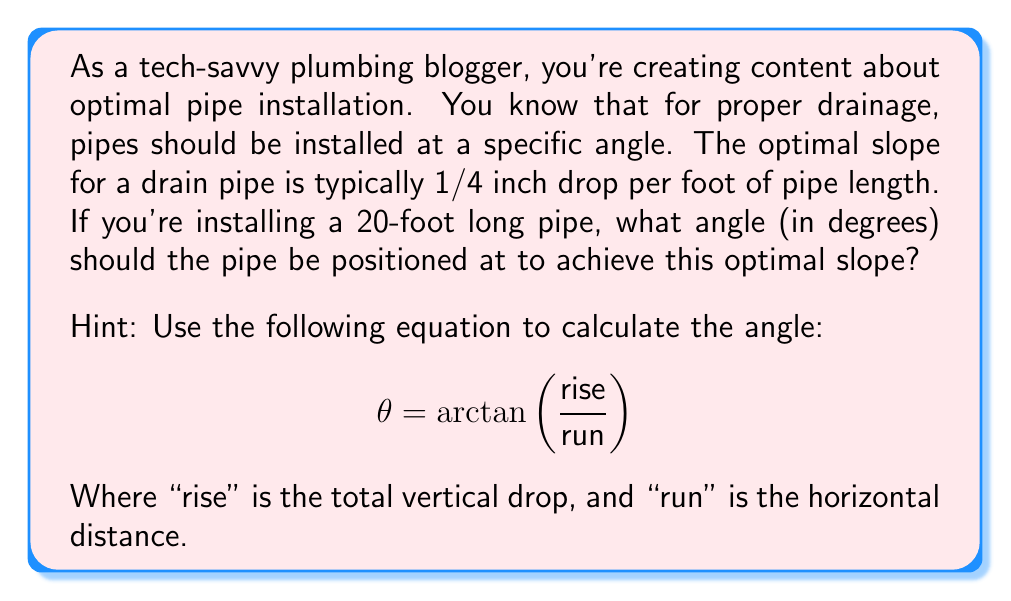Teach me how to tackle this problem. To solve this problem, we'll follow these steps:

1. Calculate the total vertical drop (rise):
   - The optimal slope is 1/4 inch per foot
   - For a 20-foot pipe: $20 \times 1/4 = 5$ inches of total drop

2. Convert the rise and run to the same units:
   - Rise: 5 inches
   - Run: 20 feet = 240 inches

3. Use the arctangent function to calculate the angle:
   $$\theta = \arctan\left(\frac{\text{rise}}{\text{run}}\right)$$
   $$\theta = \arctan\left(\frac{5}{240}\right)$$

4. Calculate the result:
   $$\theta = \arctan(0.0208333...)$$
   $$\theta \approx 1.19^\circ$$

5. Round to two decimal places:
   $$\theta \approx 1.19^\circ$$

This angle ensures the optimal slope of 1/4 inch drop per foot over the 20-foot pipe length, maximizing drainage efficiency.

[asy]
import geometry;

size(200);
real angle = atan(5/240);
pair A = (0,0), B = (240*cos(angle), 240*sin(angle));
draw(A--B, arrow=Arrow(TeXHead));
draw(A--(240,0), dashed);
draw((240,0)--B, dashed);

label("20 ft (240 in)", (120,0), S);
label("5 in", (240,2.5), E);
label("θ", (10,5));

dot("A", A, SW);
dot("B", B, NE);
[/asy]
Answer: The optimal angle for the 20-foot pipe installation is approximately $1.19^\circ$. 